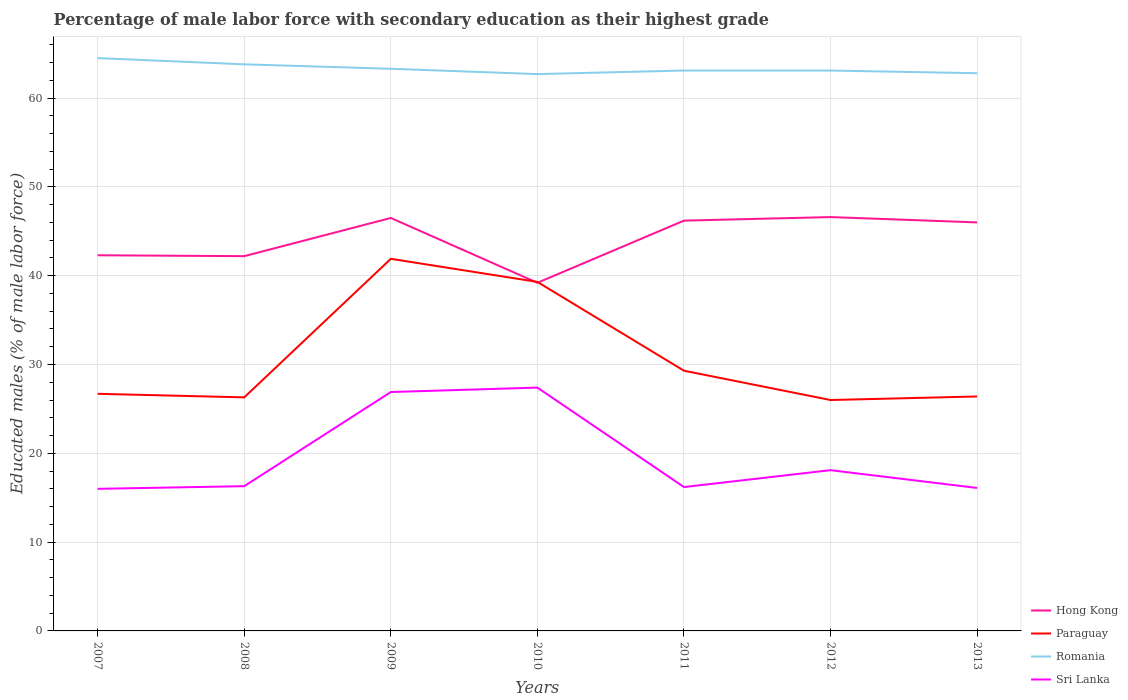How many different coloured lines are there?
Provide a short and direct response. 4. Does the line corresponding to Sri Lanka intersect with the line corresponding to Romania?
Your answer should be very brief. No. Is the number of lines equal to the number of legend labels?
Your answer should be very brief. Yes. What is the total percentage of male labor force with secondary education in Romania in the graph?
Provide a succinct answer. 0. What is the difference between the highest and the second highest percentage of male labor force with secondary education in Sri Lanka?
Make the answer very short. 11.4. What is the difference between the highest and the lowest percentage of male labor force with secondary education in Paraguay?
Provide a succinct answer. 2. Is the percentage of male labor force with secondary education in Hong Kong strictly greater than the percentage of male labor force with secondary education in Paraguay over the years?
Your answer should be compact. No. Are the values on the major ticks of Y-axis written in scientific E-notation?
Offer a terse response. No. How are the legend labels stacked?
Offer a terse response. Vertical. What is the title of the graph?
Offer a very short reply. Percentage of male labor force with secondary education as their highest grade. Does "Burundi" appear as one of the legend labels in the graph?
Provide a short and direct response. No. What is the label or title of the Y-axis?
Make the answer very short. Educated males (% of male labor force). What is the Educated males (% of male labor force) in Hong Kong in 2007?
Your answer should be very brief. 42.3. What is the Educated males (% of male labor force) in Paraguay in 2007?
Ensure brevity in your answer.  26.7. What is the Educated males (% of male labor force) in Romania in 2007?
Ensure brevity in your answer.  64.5. What is the Educated males (% of male labor force) in Sri Lanka in 2007?
Offer a very short reply. 16. What is the Educated males (% of male labor force) in Hong Kong in 2008?
Keep it short and to the point. 42.2. What is the Educated males (% of male labor force) in Paraguay in 2008?
Provide a succinct answer. 26.3. What is the Educated males (% of male labor force) in Romania in 2008?
Provide a short and direct response. 63.8. What is the Educated males (% of male labor force) of Sri Lanka in 2008?
Provide a short and direct response. 16.3. What is the Educated males (% of male labor force) in Hong Kong in 2009?
Provide a succinct answer. 46.5. What is the Educated males (% of male labor force) in Paraguay in 2009?
Provide a succinct answer. 41.9. What is the Educated males (% of male labor force) of Romania in 2009?
Make the answer very short. 63.3. What is the Educated males (% of male labor force) of Sri Lanka in 2009?
Offer a terse response. 26.9. What is the Educated males (% of male labor force) in Hong Kong in 2010?
Your response must be concise. 39.2. What is the Educated males (% of male labor force) in Paraguay in 2010?
Make the answer very short. 39.3. What is the Educated males (% of male labor force) in Romania in 2010?
Your answer should be very brief. 62.7. What is the Educated males (% of male labor force) of Sri Lanka in 2010?
Provide a short and direct response. 27.4. What is the Educated males (% of male labor force) of Hong Kong in 2011?
Provide a succinct answer. 46.2. What is the Educated males (% of male labor force) of Paraguay in 2011?
Keep it short and to the point. 29.3. What is the Educated males (% of male labor force) of Romania in 2011?
Make the answer very short. 63.1. What is the Educated males (% of male labor force) of Sri Lanka in 2011?
Your response must be concise. 16.2. What is the Educated males (% of male labor force) of Hong Kong in 2012?
Offer a very short reply. 46.6. What is the Educated males (% of male labor force) of Romania in 2012?
Your answer should be compact. 63.1. What is the Educated males (% of male labor force) of Sri Lanka in 2012?
Ensure brevity in your answer.  18.1. What is the Educated males (% of male labor force) of Paraguay in 2013?
Provide a succinct answer. 26.4. What is the Educated males (% of male labor force) of Romania in 2013?
Keep it short and to the point. 62.8. What is the Educated males (% of male labor force) in Sri Lanka in 2013?
Keep it short and to the point. 16.1. Across all years, what is the maximum Educated males (% of male labor force) of Hong Kong?
Provide a short and direct response. 46.6. Across all years, what is the maximum Educated males (% of male labor force) in Paraguay?
Your response must be concise. 41.9. Across all years, what is the maximum Educated males (% of male labor force) of Romania?
Keep it short and to the point. 64.5. Across all years, what is the maximum Educated males (% of male labor force) of Sri Lanka?
Your answer should be compact. 27.4. Across all years, what is the minimum Educated males (% of male labor force) of Hong Kong?
Give a very brief answer. 39.2. Across all years, what is the minimum Educated males (% of male labor force) of Romania?
Your answer should be compact. 62.7. Across all years, what is the minimum Educated males (% of male labor force) in Sri Lanka?
Keep it short and to the point. 16. What is the total Educated males (% of male labor force) in Hong Kong in the graph?
Your answer should be very brief. 309. What is the total Educated males (% of male labor force) in Paraguay in the graph?
Ensure brevity in your answer.  215.9. What is the total Educated males (% of male labor force) of Romania in the graph?
Your response must be concise. 443.3. What is the total Educated males (% of male labor force) in Sri Lanka in the graph?
Ensure brevity in your answer.  137. What is the difference between the Educated males (% of male labor force) in Hong Kong in 2007 and that in 2008?
Give a very brief answer. 0.1. What is the difference between the Educated males (% of male labor force) in Romania in 2007 and that in 2008?
Offer a terse response. 0.7. What is the difference between the Educated males (% of male labor force) of Paraguay in 2007 and that in 2009?
Your answer should be very brief. -15.2. What is the difference between the Educated males (% of male labor force) in Romania in 2007 and that in 2009?
Provide a succinct answer. 1.2. What is the difference between the Educated males (% of male labor force) in Paraguay in 2007 and that in 2010?
Your response must be concise. -12.6. What is the difference between the Educated males (% of male labor force) in Romania in 2007 and that in 2010?
Make the answer very short. 1.8. What is the difference between the Educated males (% of male labor force) of Sri Lanka in 2007 and that in 2010?
Keep it short and to the point. -11.4. What is the difference between the Educated males (% of male labor force) of Sri Lanka in 2007 and that in 2011?
Make the answer very short. -0.2. What is the difference between the Educated males (% of male labor force) in Paraguay in 2007 and that in 2012?
Your answer should be compact. 0.7. What is the difference between the Educated males (% of male labor force) in Romania in 2007 and that in 2012?
Your answer should be compact. 1.4. What is the difference between the Educated males (% of male labor force) of Sri Lanka in 2007 and that in 2012?
Give a very brief answer. -2.1. What is the difference between the Educated males (% of male labor force) in Hong Kong in 2007 and that in 2013?
Provide a succinct answer. -3.7. What is the difference between the Educated males (% of male labor force) of Paraguay in 2007 and that in 2013?
Keep it short and to the point. 0.3. What is the difference between the Educated males (% of male labor force) of Sri Lanka in 2007 and that in 2013?
Provide a succinct answer. -0.1. What is the difference between the Educated males (% of male labor force) of Hong Kong in 2008 and that in 2009?
Offer a terse response. -4.3. What is the difference between the Educated males (% of male labor force) in Paraguay in 2008 and that in 2009?
Provide a succinct answer. -15.6. What is the difference between the Educated males (% of male labor force) in Paraguay in 2008 and that in 2010?
Offer a very short reply. -13. What is the difference between the Educated males (% of male labor force) in Sri Lanka in 2008 and that in 2010?
Your response must be concise. -11.1. What is the difference between the Educated males (% of male labor force) in Hong Kong in 2008 and that in 2011?
Offer a very short reply. -4. What is the difference between the Educated males (% of male labor force) in Sri Lanka in 2008 and that in 2011?
Make the answer very short. 0.1. What is the difference between the Educated males (% of male labor force) of Hong Kong in 2008 and that in 2012?
Offer a very short reply. -4.4. What is the difference between the Educated males (% of male labor force) of Paraguay in 2008 and that in 2012?
Keep it short and to the point. 0.3. What is the difference between the Educated males (% of male labor force) of Sri Lanka in 2009 and that in 2010?
Give a very brief answer. -0.5. What is the difference between the Educated males (% of male labor force) in Paraguay in 2009 and that in 2011?
Provide a succinct answer. 12.6. What is the difference between the Educated males (% of male labor force) of Sri Lanka in 2009 and that in 2011?
Make the answer very short. 10.7. What is the difference between the Educated males (% of male labor force) in Hong Kong in 2009 and that in 2012?
Provide a short and direct response. -0.1. What is the difference between the Educated males (% of male labor force) of Paraguay in 2009 and that in 2012?
Make the answer very short. 15.9. What is the difference between the Educated males (% of male labor force) of Romania in 2009 and that in 2012?
Provide a short and direct response. 0.2. What is the difference between the Educated males (% of male labor force) in Hong Kong in 2009 and that in 2013?
Make the answer very short. 0.5. What is the difference between the Educated males (% of male labor force) of Paraguay in 2010 and that in 2011?
Your answer should be very brief. 10. What is the difference between the Educated males (% of male labor force) in Romania in 2010 and that in 2011?
Keep it short and to the point. -0.4. What is the difference between the Educated males (% of male labor force) of Hong Kong in 2010 and that in 2012?
Make the answer very short. -7.4. What is the difference between the Educated males (% of male labor force) of Paraguay in 2010 and that in 2012?
Keep it short and to the point. 13.3. What is the difference between the Educated males (% of male labor force) in Romania in 2010 and that in 2012?
Your answer should be very brief. -0.4. What is the difference between the Educated males (% of male labor force) of Sri Lanka in 2010 and that in 2012?
Your answer should be very brief. 9.3. What is the difference between the Educated males (% of male labor force) of Hong Kong in 2010 and that in 2013?
Give a very brief answer. -6.8. What is the difference between the Educated males (% of male labor force) of Hong Kong in 2011 and that in 2012?
Provide a succinct answer. -0.4. What is the difference between the Educated males (% of male labor force) in Paraguay in 2011 and that in 2012?
Give a very brief answer. 3.3. What is the difference between the Educated males (% of male labor force) in Romania in 2011 and that in 2012?
Your answer should be compact. 0. What is the difference between the Educated males (% of male labor force) in Hong Kong in 2011 and that in 2013?
Your response must be concise. 0.2. What is the difference between the Educated males (% of male labor force) of Paraguay in 2011 and that in 2013?
Make the answer very short. 2.9. What is the difference between the Educated males (% of male labor force) of Paraguay in 2012 and that in 2013?
Keep it short and to the point. -0.4. What is the difference between the Educated males (% of male labor force) of Sri Lanka in 2012 and that in 2013?
Your answer should be compact. 2. What is the difference between the Educated males (% of male labor force) of Hong Kong in 2007 and the Educated males (% of male labor force) of Paraguay in 2008?
Your answer should be very brief. 16. What is the difference between the Educated males (% of male labor force) of Hong Kong in 2007 and the Educated males (% of male labor force) of Romania in 2008?
Offer a very short reply. -21.5. What is the difference between the Educated males (% of male labor force) of Paraguay in 2007 and the Educated males (% of male labor force) of Romania in 2008?
Your answer should be compact. -37.1. What is the difference between the Educated males (% of male labor force) in Paraguay in 2007 and the Educated males (% of male labor force) in Sri Lanka in 2008?
Give a very brief answer. 10.4. What is the difference between the Educated males (% of male labor force) in Romania in 2007 and the Educated males (% of male labor force) in Sri Lanka in 2008?
Offer a terse response. 48.2. What is the difference between the Educated males (% of male labor force) in Hong Kong in 2007 and the Educated males (% of male labor force) in Romania in 2009?
Your answer should be very brief. -21. What is the difference between the Educated males (% of male labor force) of Paraguay in 2007 and the Educated males (% of male labor force) of Romania in 2009?
Make the answer very short. -36.6. What is the difference between the Educated males (% of male labor force) of Paraguay in 2007 and the Educated males (% of male labor force) of Sri Lanka in 2009?
Offer a very short reply. -0.2. What is the difference between the Educated males (% of male labor force) in Romania in 2007 and the Educated males (% of male labor force) in Sri Lanka in 2009?
Offer a terse response. 37.6. What is the difference between the Educated males (% of male labor force) of Hong Kong in 2007 and the Educated males (% of male labor force) of Paraguay in 2010?
Provide a succinct answer. 3. What is the difference between the Educated males (% of male labor force) in Hong Kong in 2007 and the Educated males (% of male labor force) in Romania in 2010?
Give a very brief answer. -20.4. What is the difference between the Educated males (% of male labor force) in Hong Kong in 2007 and the Educated males (% of male labor force) in Sri Lanka in 2010?
Give a very brief answer. 14.9. What is the difference between the Educated males (% of male labor force) in Paraguay in 2007 and the Educated males (% of male labor force) in Romania in 2010?
Your response must be concise. -36. What is the difference between the Educated males (% of male labor force) in Romania in 2007 and the Educated males (% of male labor force) in Sri Lanka in 2010?
Your answer should be very brief. 37.1. What is the difference between the Educated males (% of male labor force) in Hong Kong in 2007 and the Educated males (% of male labor force) in Paraguay in 2011?
Your answer should be compact. 13. What is the difference between the Educated males (% of male labor force) of Hong Kong in 2007 and the Educated males (% of male labor force) of Romania in 2011?
Ensure brevity in your answer.  -20.8. What is the difference between the Educated males (% of male labor force) of Hong Kong in 2007 and the Educated males (% of male labor force) of Sri Lanka in 2011?
Your response must be concise. 26.1. What is the difference between the Educated males (% of male labor force) of Paraguay in 2007 and the Educated males (% of male labor force) of Romania in 2011?
Offer a terse response. -36.4. What is the difference between the Educated males (% of male labor force) of Romania in 2007 and the Educated males (% of male labor force) of Sri Lanka in 2011?
Give a very brief answer. 48.3. What is the difference between the Educated males (% of male labor force) of Hong Kong in 2007 and the Educated males (% of male labor force) of Romania in 2012?
Give a very brief answer. -20.8. What is the difference between the Educated males (% of male labor force) in Hong Kong in 2007 and the Educated males (% of male labor force) in Sri Lanka in 2012?
Your response must be concise. 24.2. What is the difference between the Educated males (% of male labor force) of Paraguay in 2007 and the Educated males (% of male labor force) of Romania in 2012?
Your response must be concise. -36.4. What is the difference between the Educated males (% of male labor force) in Paraguay in 2007 and the Educated males (% of male labor force) in Sri Lanka in 2012?
Ensure brevity in your answer.  8.6. What is the difference between the Educated males (% of male labor force) of Romania in 2007 and the Educated males (% of male labor force) of Sri Lanka in 2012?
Your response must be concise. 46.4. What is the difference between the Educated males (% of male labor force) in Hong Kong in 2007 and the Educated males (% of male labor force) in Romania in 2013?
Give a very brief answer. -20.5. What is the difference between the Educated males (% of male labor force) in Hong Kong in 2007 and the Educated males (% of male labor force) in Sri Lanka in 2013?
Ensure brevity in your answer.  26.2. What is the difference between the Educated males (% of male labor force) in Paraguay in 2007 and the Educated males (% of male labor force) in Romania in 2013?
Make the answer very short. -36.1. What is the difference between the Educated males (% of male labor force) of Romania in 2007 and the Educated males (% of male labor force) of Sri Lanka in 2013?
Keep it short and to the point. 48.4. What is the difference between the Educated males (% of male labor force) in Hong Kong in 2008 and the Educated males (% of male labor force) in Paraguay in 2009?
Ensure brevity in your answer.  0.3. What is the difference between the Educated males (% of male labor force) of Hong Kong in 2008 and the Educated males (% of male labor force) of Romania in 2009?
Provide a short and direct response. -21.1. What is the difference between the Educated males (% of male labor force) of Paraguay in 2008 and the Educated males (% of male labor force) of Romania in 2009?
Your response must be concise. -37. What is the difference between the Educated males (% of male labor force) in Paraguay in 2008 and the Educated males (% of male labor force) in Sri Lanka in 2009?
Your response must be concise. -0.6. What is the difference between the Educated males (% of male labor force) in Romania in 2008 and the Educated males (% of male labor force) in Sri Lanka in 2009?
Your answer should be very brief. 36.9. What is the difference between the Educated males (% of male labor force) of Hong Kong in 2008 and the Educated males (% of male labor force) of Romania in 2010?
Provide a succinct answer. -20.5. What is the difference between the Educated males (% of male labor force) of Paraguay in 2008 and the Educated males (% of male labor force) of Romania in 2010?
Your answer should be very brief. -36.4. What is the difference between the Educated males (% of male labor force) of Paraguay in 2008 and the Educated males (% of male labor force) of Sri Lanka in 2010?
Your answer should be very brief. -1.1. What is the difference between the Educated males (% of male labor force) of Romania in 2008 and the Educated males (% of male labor force) of Sri Lanka in 2010?
Ensure brevity in your answer.  36.4. What is the difference between the Educated males (% of male labor force) in Hong Kong in 2008 and the Educated males (% of male labor force) in Paraguay in 2011?
Keep it short and to the point. 12.9. What is the difference between the Educated males (% of male labor force) in Hong Kong in 2008 and the Educated males (% of male labor force) in Romania in 2011?
Offer a very short reply. -20.9. What is the difference between the Educated males (% of male labor force) in Hong Kong in 2008 and the Educated males (% of male labor force) in Sri Lanka in 2011?
Give a very brief answer. 26. What is the difference between the Educated males (% of male labor force) of Paraguay in 2008 and the Educated males (% of male labor force) of Romania in 2011?
Keep it short and to the point. -36.8. What is the difference between the Educated males (% of male labor force) of Romania in 2008 and the Educated males (% of male labor force) of Sri Lanka in 2011?
Ensure brevity in your answer.  47.6. What is the difference between the Educated males (% of male labor force) of Hong Kong in 2008 and the Educated males (% of male labor force) of Romania in 2012?
Your response must be concise. -20.9. What is the difference between the Educated males (% of male labor force) in Hong Kong in 2008 and the Educated males (% of male labor force) in Sri Lanka in 2012?
Offer a very short reply. 24.1. What is the difference between the Educated males (% of male labor force) in Paraguay in 2008 and the Educated males (% of male labor force) in Romania in 2012?
Provide a succinct answer. -36.8. What is the difference between the Educated males (% of male labor force) of Paraguay in 2008 and the Educated males (% of male labor force) of Sri Lanka in 2012?
Keep it short and to the point. 8.2. What is the difference between the Educated males (% of male labor force) in Romania in 2008 and the Educated males (% of male labor force) in Sri Lanka in 2012?
Your answer should be very brief. 45.7. What is the difference between the Educated males (% of male labor force) of Hong Kong in 2008 and the Educated males (% of male labor force) of Romania in 2013?
Your answer should be very brief. -20.6. What is the difference between the Educated males (% of male labor force) of Hong Kong in 2008 and the Educated males (% of male labor force) of Sri Lanka in 2013?
Your answer should be compact. 26.1. What is the difference between the Educated males (% of male labor force) of Paraguay in 2008 and the Educated males (% of male labor force) of Romania in 2013?
Offer a very short reply. -36.5. What is the difference between the Educated males (% of male labor force) of Romania in 2008 and the Educated males (% of male labor force) of Sri Lanka in 2013?
Keep it short and to the point. 47.7. What is the difference between the Educated males (% of male labor force) in Hong Kong in 2009 and the Educated males (% of male labor force) in Romania in 2010?
Your answer should be very brief. -16.2. What is the difference between the Educated males (% of male labor force) of Paraguay in 2009 and the Educated males (% of male labor force) of Romania in 2010?
Ensure brevity in your answer.  -20.8. What is the difference between the Educated males (% of male labor force) in Romania in 2009 and the Educated males (% of male labor force) in Sri Lanka in 2010?
Provide a short and direct response. 35.9. What is the difference between the Educated males (% of male labor force) in Hong Kong in 2009 and the Educated males (% of male labor force) in Romania in 2011?
Your answer should be very brief. -16.6. What is the difference between the Educated males (% of male labor force) in Hong Kong in 2009 and the Educated males (% of male labor force) in Sri Lanka in 2011?
Your answer should be compact. 30.3. What is the difference between the Educated males (% of male labor force) in Paraguay in 2009 and the Educated males (% of male labor force) in Romania in 2011?
Ensure brevity in your answer.  -21.2. What is the difference between the Educated males (% of male labor force) in Paraguay in 2009 and the Educated males (% of male labor force) in Sri Lanka in 2011?
Offer a terse response. 25.7. What is the difference between the Educated males (% of male labor force) of Romania in 2009 and the Educated males (% of male labor force) of Sri Lanka in 2011?
Your answer should be very brief. 47.1. What is the difference between the Educated males (% of male labor force) of Hong Kong in 2009 and the Educated males (% of male labor force) of Paraguay in 2012?
Give a very brief answer. 20.5. What is the difference between the Educated males (% of male labor force) of Hong Kong in 2009 and the Educated males (% of male labor force) of Romania in 2012?
Offer a very short reply. -16.6. What is the difference between the Educated males (% of male labor force) in Hong Kong in 2009 and the Educated males (% of male labor force) in Sri Lanka in 2012?
Offer a terse response. 28.4. What is the difference between the Educated males (% of male labor force) of Paraguay in 2009 and the Educated males (% of male labor force) of Romania in 2012?
Make the answer very short. -21.2. What is the difference between the Educated males (% of male labor force) in Paraguay in 2009 and the Educated males (% of male labor force) in Sri Lanka in 2012?
Keep it short and to the point. 23.8. What is the difference between the Educated males (% of male labor force) in Romania in 2009 and the Educated males (% of male labor force) in Sri Lanka in 2012?
Provide a succinct answer. 45.2. What is the difference between the Educated males (% of male labor force) in Hong Kong in 2009 and the Educated males (% of male labor force) in Paraguay in 2013?
Provide a short and direct response. 20.1. What is the difference between the Educated males (% of male labor force) of Hong Kong in 2009 and the Educated males (% of male labor force) of Romania in 2013?
Give a very brief answer. -16.3. What is the difference between the Educated males (% of male labor force) in Hong Kong in 2009 and the Educated males (% of male labor force) in Sri Lanka in 2013?
Give a very brief answer. 30.4. What is the difference between the Educated males (% of male labor force) of Paraguay in 2009 and the Educated males (% of male labor force) of Romania in 2013?
Offer a terse response. -20.9. What is the difference between the Educated males (% of male labor force) in Paraguay in 2009 and the Educated males (% of male labor force) in Sri Lanka in 2013?
Make the answer very short. 25.8. What is the difference between the Educated males (% of male labor force) in Romania in 2009 and the Educated males (% of male labor force) in Sri Lanka in 2013?
Provide a succinct answer. 47.2. What is the difference between the Educated males (% of male labor force) of Hong Kong in 2010 and the Educated males (% of male labor force) of Paraguay in 2011?
Your answer should be very brief. 9.9. What is the difference between the Educated males (% of male labor force) of Hong Kong in 2010 and the Educated males (% of male labor force) of Romania in 2011?
Ensure brevity in your answer.  -23.9. What is the difference between the Educated males (% of male labor force) in Paraguay in 2010 and the Educated males (% of male labor force) in Romania in 2011?
Offer a terse response. -23.8. What is the difference between the Educated males (% of male labor force) in Paraguay in 2010 and the Educated males (% of male labor force) in Sri Lanka in 2011?
Keep it short and to the point. 23.1. What is the difference between the Educated males (% of male labor force) in Romania in 2010 and the Educated males (% of male labor force) in Sri Lanka in 2011?
Provide a short and direct response. 46.5. What is the difference between the Educated males (% of male labor force) in Hong Kong in 2010 and the Educated males (% of male labor force) in Paraguay in 2012?
Offer a terse response. 13.2. What is the difference between the Educated males (% of male labor force) in Hong Kong in 2010 and the Educated males (% of male labor force) in Romania in 2012?
Provide a short and direct response. -23.9. What is the difference between the Educated males (% of male labor force) of Hong Kong in 2010 and the Educated males (% of male labor force) of Sri Lanka in 2012?
Make the answer very short. 21.1. What is the difference between the Educated males (% of male labor force) of Paraguay in 2010 and the Educated males (% of male labor force) of Romania in 2012?
Provide a short and direct response. -23.8. What is the difference between the Educated males (% of male labor force) of Paraguay in 2010 and the Educated males (% of male labor force) of Sri Lanka in 2012?
Your answer should be very brief. 21.2. What is the difference between the Educated males (% of male labor force) in Romania in 2010 and the Educated males (% of male labor force) in Sri Lanka in 2012?
Make the answer very short. 44.6. What is the difference between the Educated males (% of male labor force) of Hong Kong in 2010 and the Educated males (% of male labor force) of Romania in 2013?
Offer a terse response. -23.6. What is the difference between the Educated males (% of male labor force) of Hong Kong in 2010 and the Educated males (% of male labor force) of Sri Lanka in 2013?
Your answer should be very brief. 23.1. What is the difference between the Educated males (% of male labor force) in Paraguay in 2010 and the Educated males (% of male labor force) in Romania in 2013?
Your answer should be compact. -23.5. What is the difference between the Educated males (% of male labor force) of Paraguay in 2010 and the Educated males (% of male labor force) of Sri Lanka in 2013?
Your answer should be compact. 23.2. What is the difference between the Educated males (% of male labor force) in Romania in 2010 and the Educated males (% of male labor force) in Sri Lanka in 2013?
Keep it short and to the point. 46.6. What is the difference between the Educated males (% of male labor force) in Hong Kong in 2011 and the Educated males (% of male labor force) in Paraguay in 2012?
Keep it short and to the point. 20.2. What is the difference between the Educated males (% of male labor force) of Hong Kong in 2011 and the Educated males (% of male labor force) of Romania in 2012?
Keep it short and to the point. -16.9. What is the difference between the Educated males (% of male labor force) of Hong Kong in 2011 and the Educated males (% of male labor force) of Sri Lanka in 2012?
Give a very brief answer. 28.1. What is the difference between the Educated males (% of male labor force) in Paraguay in 2011 and the Educated males (% of male labor force) in Romania in 2012?
Your response must be concise. -33.8. What is the difference between the Educated males (% of male labor force) of Paraguay in 2011 and the Educated males (% of male labor force) of Sri Lanka in 2012?
Provide a short and direct response. 11.2. What is the difference between the Educated males (% of male labor force) in Romania in 2011 and the Educated males (% of male labor force) in Sri Lanka in 2012?
Make the answer very short. 45. What is the difference between the Educated males (% of male labor force) of Hong Kong in 2011 and the Educated males (% of male labor force) of Paraguay in 2013?
Keep it short and to the point. 19.8. What is the difference between the Educated males (% of male labor force) in Hong Kong in 2011 and the Educated males (% of male labor force) in Romania in 2013?
Your response must be concise. -16.6. What is the difference between the Educated males (% of male labor force) of Hong Kong in 2011 and the Educated males (% of male labor force) of Sri Lanka in 2013?
Your answer should be compact. 30.1. What is the difference between the Educated males (% of male labor force) of Paraguay in 2011 and the Educated males (% of male labor force) of Romania in 2013?
Provide a succinct answer. -33.5. What is the difference between the Educated males (% of male labor force) of Paraguay in 2011 and the Educated males (% of male labor force) of Sri Lanka in 2013?
Your response must be concise. 13.2. What is the difference between the Educated males (% of male labor force) in Hong Kong in 2012 and the Educated males (% of male labor force) in Paraguay in 2013?
Your response must be concise. 20.2. What is the difference between the Educated males (% of male labor force) in Hong Kong in 2012 and the Educated males (% of male labor force) in Romania in 2013?
Provide a succinct answer. -16.2. What is the difference between the Educated males (% of male labor force) in Hong Kong in 2012 and the Educated males (% of male labor force) in Sri Lanka in 2013?
Make the answer very short. 30.5. What is the difference between the Educated males (% of male labor force) in Paraguay in 2012 and the Educated males (% of male labor force) in Romania in 2013?
Offer a terse response. -36.8. What is the difference between the Educated males (% of male labor force) of Paraguay in 2012 and the Educated males (% of male labor force) of Sri Lanka in 2013?
Offer a terse response. 9.9. What is the difference between the Educated males (% of male labor force) of Romania in 2012 and the Educated males (% of male labor force) of Sri Lanka in 2013?
Ensure brevity in your answer.  47. What is the average Educated males (% of male labor force) in Hong Kong per year?
Keep it short and to the point. 44.14. What is the average Educated males (% of male labor force) in Paraguay per year?
Offer a terse response. 30.84. What is the average Educated males (% of male labor force) in Romania per year?
Your response must be concise. 63.33. What is the average Educated males (% of male labor force) of Sri Lanka per year?
Provide a short and direct response. 19.57. In the year 2007, what is the difference between the Educated males (% of male labor force) in Hong Kong and Educated males (% of male labor force) in Romania?
Offer a very short reply. -22.2. In the year 2007, what is the difference between the Educated males (% of male labor force) in Hong Kong and Educated males (% of male labor force) in Sri Lanka?
Provide a succinct answer. 26.3. In the year 2007, what is the difference between the Educated males (% of male labor force) of Paraguay and Educated males (% of male labor force) of Romania?
Provide a succinct answer. -37.8. In the year 2007, what is the difference between the Educated males (% of male labor force) in Paraguay and Educated males (% of male labor force) in Sri Lanka?
Ensure brevity in your answer.  10.7. In the year 2007, what is the difference between the Educated males (% of male labor force) of Romania and Educated males (% of male labor force) of Sri Lanka?
Provide a short and direct response. 48.5. In the year 2008, what is the difference between the Educated males (% of male labor force) of Hong Kong and Educated males (% of male labor force) of Romania?
Your answer should be very brief. -21.6. In the year 2008, what is the difference between the Educated males (% of male labor force) of Hong Kong and Educated males (% of male labor force) of Sri Lanka?
Give a very brief answer. 25.9. In the year 2008, what is the difference between the Educated males (% of male labor force) of Paraguay and Educated males (% of male labor force) of Romania?
Ensure brevity in your answer.  -37.5. In the year 2008, what is the difference between the Educated males (% of male labor force) in Paraguay and Educated males (% of male labor force) in Sri Lanka?
Give a very brief answer. 10. In the year 2008, what is the difference between the Educated males (% of male labor force) in Romania and Educated males (% of male labor force) in Sri Lanka?
Provide a short and direct response. 47.5. In the year 2009, what is the difference between the Educated males (% of male labor force) of Hong Kong and Educated males (% of male labor force) of Paraguay?
Provide a short and direct response. 4.6. In the year 2009, what is the difference between the Educated males (% of male labor force) of Hong Kong and Educated males (% of male labor force) of Romania?
Keep it short and to the point. -16.8. In the year 2009, what is the difference between the Educated males (% of male labor force) in Hong Kong and Educated males (% of male labor force) in Sri Lanka?
Ensure brevity in your answer.  19.6. In the year 2009, what is the difference between the Educated males (% of male labor force) in Paraguay and Educated males (% of male labor force) in Romania?
Your answer should be compact. -21.4. In the year 2009, what is the difference between the Educated males (% of male labor force) in Paraguay and Educated males (% of male labor force) in Sri Lanka?
Provide a short and direct response. 15. In the year 2009, what is the difference between the Educated males (% of male labor force) in Romania and Educated males (% of male labor force) in Sri Lanka?
Offer a very short reply. 36.4. In the year 2010, what is the difference between the Educated males (% of male labor force) of Hong Kong and Educated males (% of male labor force) of Romania?
Provide a short and direct response. -23.5. In the year 2010, what is the difference between the Educated males (% of male labor force) in Hong Kong and Educated males (% of male labor force) in Sri Lanka?
Your answer should be compact. 11.8. In the year 2010, what is the difference between the Educated males (% of male labor force) of Paraguay and Educated males (% of male labor force) of Romania?
Ensure brevity in your answer.  -23.4. In the year 2010, what is the difference between the Educated males (% of male labor force) of Romania and Educated males (% of male labor force) of Sri Lanka?
Your answer should be very brief. 35.3. In the year 2011, what is the difference between the Educated males (% of male labor force) of Hong Kong and Educated males (% of male labor force) of Romania?
Your answer should be compact. -16.9. In the year 2011, what is the difference between the Educated males (% of male labor force) of Hong Kong and Educated males (% of male labor force) of Sri Lanka?
Make the answer very short. 30. In the year 2011, what is the difference between the Educated males (% of male labor force) of Paraguay and Educated males (% of male labor force) of Romania?
Provide a succinct answer. -33.8. In the year 2011, what is the difference between the Educated males (% of male labor force) in Romania and Educated males (% of male labor force) in Sri Lanka?
Offer a very short reply. 46.9. In the year 2012, what is the difference between the Educated males (% of male labor force) of Hong Kong and Educated males (% of male labor force) of Paraguay?
Offer a terse response. 20.6. In the year 2012, what is the difference between the Educated males (% of male labor force) of Hong Kong and Educated males (% of male labor force) of Romania?
Provide a short and direct response. -16.5. In the year 2012, what is the difference between the Educated males (% of male labor force) of Hong Kong and Educated males (% of male labor force) of Sri Lanka?
Offer a terse response. 28.5. In the year 2012, what is the difference between the Educated males (% of male labor force) of Paraguay and Educated males (% of male labor force) of Romania?
Provide a short and direct response. -37.1. In the year 2012, what is the difference between the Educated males (% of male labor force) of Romania and Educated males (% of male labor force) of Sri Lanka?
Offer a terse response. 45. In the year 2013, what is the difference between the Educated males (% of male labor force) in Hong Kong and Educated males (% of male labor force) in Paraguay?
Provide a succinct answer. 19.6. In the year 2013, what is the difference between the Educated males (% of male labor force) in Hong Kong and Educated males (% of male labor force) in Romania?
Your answer should be compact. -16.8. In the year 2013, what is the difference between the Educated males (% of male labor force) in Hong Kong and Educated males (% of male labor force) in Sri Lanka?
Provide a short and direct response. 29.9. In the year 2013, what is the difference between the Educated males (% of male labor force) of Paraguay and Educated males (% of male labor force) of Romania?
Ensure brevity in your answer.  -36.4. In the year 2013, what is the difference between the Educated males (% of male labor force) in Romania and Educated males (% of male labor force) in Sri Lanka?
Offer a very short reply. 46.7. What is the ratio of the Educated males (% of male labor force) of Hong Kong in 2007 to that in 2008?
Your response must be concise. 1. What is the ratio of the Educated males (% of male labor force) of Paraguay in 2007 to that in 2008?
Give a very brief answer. 1.02. What is the ratio of the Educated males (% of male labor force) in Sri Lanka in 2007 to that in 2008?
Ensure brevity in your answer.  0.98. What is the ratio of the Educated males (% of male labor force) in Hong Kong in 2007 to that in 2009?
Provide a succinct answer. 0.91. What is the ratio of the Educated males (% of male labor force) of Paraguay in 2007 to that in 2009?
Offer a very short reply. 0.64. What is the ratio of the Educated males (% of male labor force) in Sri Lanka in 2007 to that in 2009?
Make the answer very short. 0.59. What is the ratio of the Educated males (% of male labor force) of Hong Kong in 2007 to that in 2010?
Offer a very short reply. 1.08. What is the ratio of the Educated males (% of male labor force) in Paraguay in 2007 to that in 2010?
Your response must be concise. 0.68. What is the ratio of the Educated males (% of male labor force) in Romania in 2007 to that in 2010?
Ensure brevity in your answer.  1.03. What is the ratio of the Educated males (% of male labor force) of Sri Lanka in 2007 to that in 2010?
Make the answer very short. 0.58. What is the ratio of the Educated males (% of male labor force) of Hong Kong in 2007 to that in 2011?
Your answer should be compact. 0.92. What is the ratio of the Educated males (% of male labor force) in Paraguay in 2007 to that in 2011?
Your answer should be very brief. 0.91. What is the ratio of the Educated males (% of male labor force) of Romania in 2007 to that in 2011?
Your response must be concise. 1.02. What is the ratio of the Educated males (% of male labor force) in Sri Lanka in 2007 to that in 2011?
Your response must be concise. 0.99. What is the ratio of the Educated males (% of male labor force) in Hong Kong in 2007 to that in 2012?
Provide a short and direct response. 0.91. What is the ratio of the Educated males (% of male labor force) of Paraguay in 2007 to that in 2012?
Your answer should be very brief. 1.03. What is the ratio of the Educated males (% of male labor force) of Romania in 2007 to that in 2012?
Offer a terse response. 1.02. What is the ratio of the Educated males (% of male labor force) of Sri Lanka in 2007 to that in 2012?
Your answer should be compact. 0.88. What is the ratio of the Educated males (% of male labor force) in Hong Kong in 2007 to that in 2013?
Your answer should be compact. 0.92. What is the ratio of the Educated males (% of male labor force) in Paraguay in 2007 to that in 2013?
Provide a short and direct response. 1.01. What is the ratio of the Educated males (% of male labor force) of Romania in 2007 to that in 2013?
Make the answer very short. 1.03. What is the ratio of the Educated males (% of male labor force) in Sri Lanka in 2007 to that in 2013?
Ensure brevity in your answer.  0.99. What is the ratio of the Educated males (% of male labor force) in Hong Kong in 2008 to that in 2009?
Make the answer very short. 0.91. What is the ratio of the Educated males (% of male labor force) of Paraguay in 2008 to that in 2009?
Ensure brevity in your answer.  0.63. What is the ratio of the Educated males (% of male labor force) of Romania in 2008 to that in 2009?
Your response must be concise. 1.01. What is the ratio of the Educated males (% of male labor force) of Sri Lanka in 2008 to that in 2009?
Offer a very short reply. 0.61. What is the ratio of the Educated males (% of male labor force) in Hong Kong in 2008 to that in 2010?
Keep it short and to the point. 1.08. What is the ratio of the Educated males (% of male labor force) in Paraguay in 2008 to that in 2010?
Give a very brief answer. 0.67. What is the ratio of the Educated males (% of male labor force) of Romania in 2008 to that in 2010?
Offer a very short reply. 1.02. What is the ratio of the Educated males (% of male labor force) in Sri Lanka in 2008 to that in 2010?
Make the answer very short. 0.59. What is the ratio of the Educated males (% of male labor force) in Hong Kong in 2008 to that in 2011?
Provide a succinct answer. 0.91. What is the ratio of the Educated males (% of male labor force) in Paraguay in 2008 to that in 2011?
Ensure brevity in your answer.  0.9. What is the ratio of the Educated males (% of male labor force) in Romania in 2008 to that in 2011?
Provide a succinct answer. 1.01. What is the ratio of the Educated males (% of male labor force) in Hong Kong in 2008 to that in 2012?
Give a very brief answer. 0.91. What is the ratio of the Educated males (% of male labor force) in Paraguay in 2008 to that in 2012?
Your answer should be very brief. 1.01. What is the ratio of the Educated males (% of male labor force) in Romania in 2008 to that in 2012?
Ensure brevity in your answer.  1.01. What is the ratio of the Educated males (% of male labor force) in Sri Lanka in 2008 to that in 2012?
Provide a succinct answer. 0.9. What is the ratio of the Educated males (% of male labor force) in Hong Kong in 2008 to that in 2013?
Ensure brevity in your answer.  0.92. What is the ratio of the Educated males (% of male labor force) of Romania in 2008 to that in 2013?
Your answer should be very brief. 1.02. What is the ratio of the Educated males (% of male labor force) of Sri Lanka in 2008 to that in 2013?
Ensure brevity in your answer.  1.01. What is the ratio of the Educated males (% of male labor force) of Hong Kong in 2009 to that in 2010?
Make the answer very short. 1.19. What is the ratio of the Educated males (% of male labor force) in Paraguay in 2009 to that in 2010?
Give a very brief answer. 1.07. What is the ratio of the Educated males (% of male labor force) in Romania in 2009 to that in 2010?
Ensure brevity in your answer.  1.01. What is the ratio of the Educated males (% of male labor force) in Sri Lanka in 2009 to that in 2010?
Provide a short and direct response. 0.98. What is the ratio of the Educated males (% of male labor force) of Paraguay in 2009 to that in 2011?
Make the answer very short. 1.43. What is the ratio of the Educated males (% of male labor force) of Romania in 2009 to that in 2011?
Offer a terse response. 1. What is the ratio of the Educated males (% of male labor force) in Sri Lanka in 2009 to that in 2011?
Your response must be concise. 1.66. What is the ratio of the Educated males (% of male labor force) in Paraguay in 2009 to that in 2012?
Keep it short and to the point. 1.61. What is the ratio of the Educated males (% of male labor force) in Romania in 2009 to that in 2012?
Ensure brevity in your answer.  1. What is the ratio of the Educated males (% of male labor force) in Sri Lanka in 2009 to that in 2012?
Make the answer very short. 1.49. What is the ratio of the Educated males (% of male labor force) in Hong Kong in 2009 to that in 2013?
Keep it short and to the point. 1.01. What is the ratio of the Educated males (% of male labor force) in Paraguay in 2009 to that in 2013?
Keep it short and to the point. 1.59. What is the ratio of the Educated males (% of male labor force) in Romania in 2009 to that in 2013?
Your answer should be very brief. 1.01. What is the ratio of the Educated males (% of male labor force) of Sri Lanka in 2009 to that in 2013?
Provide a succinct answer. 1.67. What is the ratio of the Educated males (% of male labor force) in Hong Kong in 2010 to that in 2011?
Your answer should be compact. 0.85. What is the ratio of the Educated males (% of male labor force) of Paraguay in 2010 to that in 2011?
Your answer should be very brief. 1.34. What is the ratio of the Educated males (% of male labor force) of Sri Lanka in 2010 to that in 2011?
Provide a short and direct response. 1.69. What is the ratio of the Educated males (% of male labor force) of Hong Kong in 2010 to that in 2012?
Your answer should be very brief. 0.84. What is the ratio of the Educated males (% of male labor force) of Paraguay in 2010 to that in 2012?
Provide a succinct answer. 1.51. What is the ratio of the Educated males (% of male labor force) of Sri Lanka in 2010 to that in 2012?
Provide a short and direct response. 1.51. What is the ratio of the Educated males (% of male labor force) of Hong Kong in 2010 to that in 2013?
Ensure brevity in your answer.  0.85. What is the ratio of the Educated males (% of male labor force) of Paraguay in 2010 to that in 2013?
Your answer should be very brief. 1.49. What is the ratio of the Educated males (% of male labor force) of Sri Lanka in 2010 to that in 2013?
Provide a short and direct response. 1.7. What is the ratio of the Educated males (% of male labor force) in Paraguay in 2011 to that in 2012?
Offer a terse response. 1.13. What is the ratio of the Educated males (% of male labor force) of Romania in 2011 to that in 2012?
Keep it short and to the point. 1. What is the ratio of the Educated males (% of male labor force) in Sri Lanka in 2011 to that in 2012?
Ensure brevity in your answer.  0.9. What is the ratio of the Educated males (% of male labor force) of Paraguay in 2011 to that in 2013?
Your answer should be compact. 1.11. What is the ratio of the Educated males (% of male labor force) in Romania in 2011 to that in 2013?
Offer a very short reply. 1. What is the ratio of the Educated males (% of male labor force) of Sri Lanka in 2011 to that in 2013?
Ensure brevity in your answer.  1.01. What is the ratio of the Educated males (% of male labor force) of Hong Kong in 2012 to that in 2013?
Your answer should be compact. 1.01. What is the ratio of the Educated males (% of male labor force) in Paraguay in 2012 to that in 2013?
Provide a succinct answer. 0.98. What is the ratio of the Educated males (% of male labor force) in Romania in 2012 to that in 2013?
Provide a short and direct response. 1. What is the ratio of the Educated males (% of male labor force) in Sri Lanka in 2012 to that in 2013?
Ensure brevity in your answer.  1.12. What is the difference between the highest and the second highest Educated males (% of male labor force) in Hong Kong?
Your response must be concise. 0.1. What is the difference between the highest and the second highest Educated males (% of male labor force) of Paraguay?
Offer a terse response. 2.6. What is the difference between the highest and the second highest Educated males (% of male labor force) in Romania?
Your answer should be compact. 0.7. What is the difference between the highest and the lowest Educated males (% of male labor force) of Hong Kong?
Offer a very short reply. 7.4. What is the difference between the highest and the lowest Educated males (% of male labor force) in Paraguay?
Ensure brevity in your answer.  15.9. What is the difference between the highest and the lowest Educated males (% of male labor force) in Romania?
Provide a short and direct response. 1.8. What is the difference between the highest and the lowest Educated males (% of male labor force) of Sri Lanka?
Your answer should be compact. 11.4. 